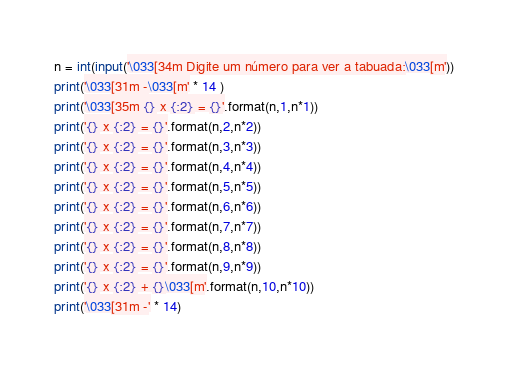<code> <loc_0><loc_0><loc_500><loc_500><_Python_>n = int(input('\033[34m Digite um número para ver a tabuada:\033[m'))
print('\033[31m -\033[m' * 14 )
print('\033[35m {} x {:2} = {}'.format(n,1,n*1))
print('{} x {:2} = {}'.format(n,2,n*2))
print('{} x {:2} = {}'.format(n,3,n*3))
print('{} x {:2} = {}'.format(n,4,n*4))
print('{} x {:2} = {}'.format(n,5,n*5))
print('{} x {:2} = {}'.format(n,6,n*6))
print('{} x {:2} = {}'.format(n,7,n*7))
print('{} x {:2} = {}'.format(n,8,n*8))
print('{} x {:2} = {}'.format(n,9,n*9))
print('{} x {:2} + {}\033[m'.format(n,10,n*10))
print('\033[31m -' * 14)
</code> 